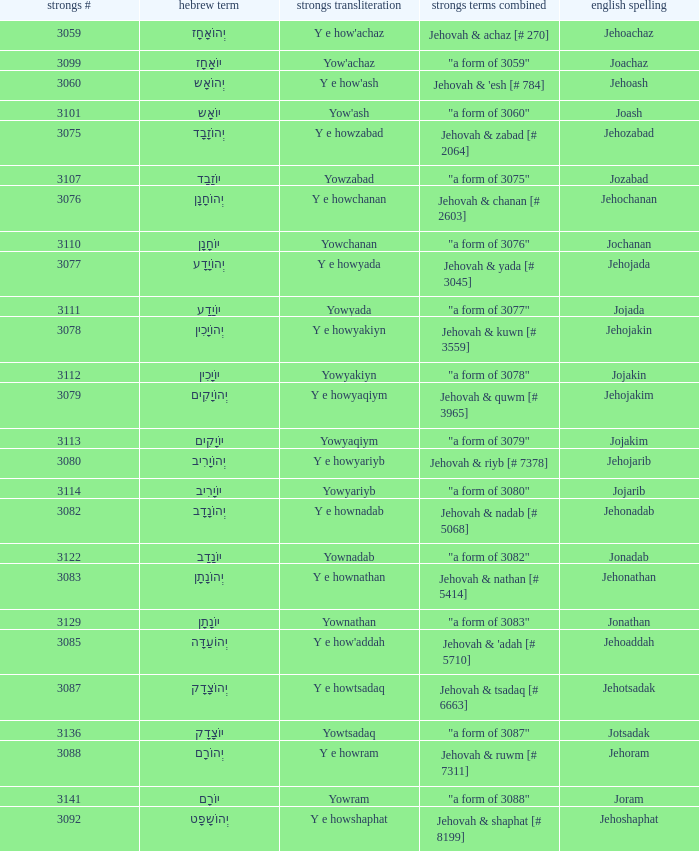What is the strong words compounded when the strongs transliteration is yowyariyb? "a form of 3080". 